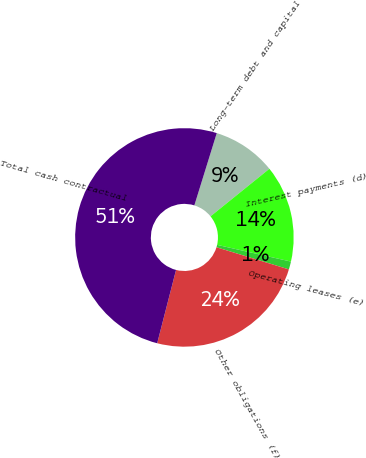Convert chart. <chart><loc_0><loc_0><loc_500><loc_500><pie_chart><fcel>Long-term debt and capital<fcel>Interest payments (d)<fcel>Operating leases (e)<fcel>Other obligations (f)<fcel>Total cash contractual<nl><fcel>9.4%<fcel>14.36%<fcel>1.18%<fcel>24.28%<fcel>50.78%<nl></chart> 